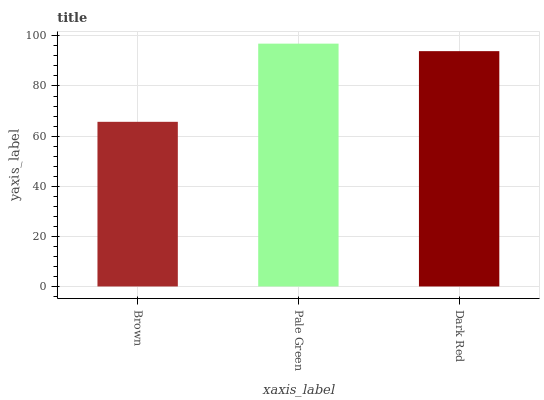Is Brown the minimum?
Answer yes or no. Yes. Is Pale Green the maximum?
Answer yes or no. Yes. Is Dark Red the minimum?
Answer yes or no. No. Is Dark Red the maximum?
Answer yes or no. No. Is Pale Green greater than Dark Red?
Answer yes or no. Yes. Is Dark Red less than Pale Green?
Answer yes or no. Yes. Is Dark Red greater than Pale Green?
Answer yes or no. No. Is Pale Green less than Dark Red?
Answer yes or no. No. Is Dark Red the high median?
Answer yes or no. Yes. Is Dark Red the low median?
Answer yes or no. Yes. Is Pale Green the high median?
Answer yes or no. No. Is Brown the low median?
Answer yes or no. No. 